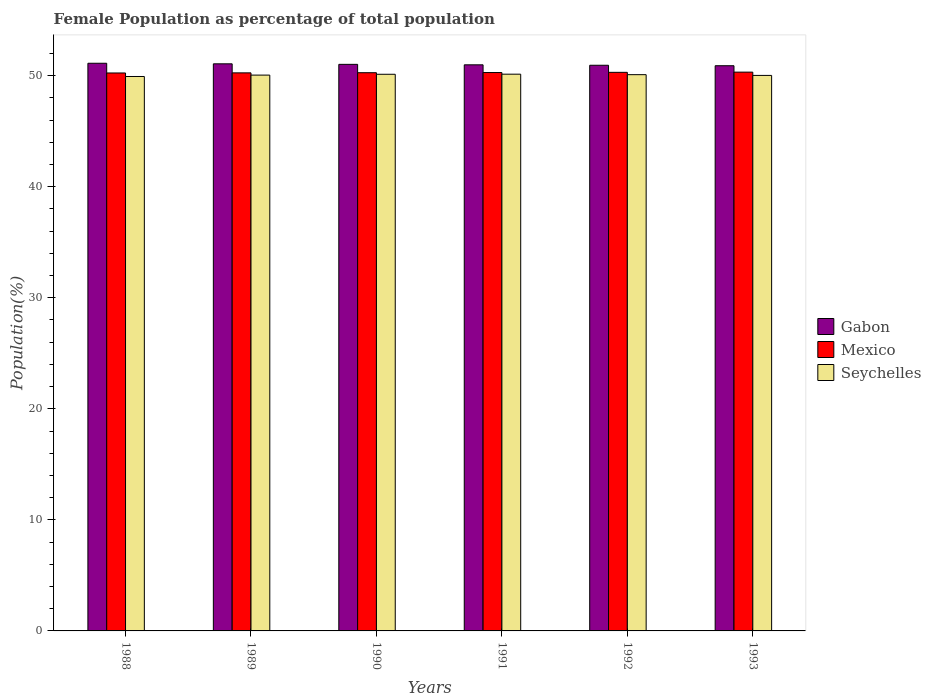Are the number of bars on each tick of the X-axis equal?
Ensure brevity in your answer.  Yes. In how many cases, is the number of bars for a given year not equal to the number of legend labels?
Your response must be concise. 0. What is the female population in in Gabon in 1991?
Offer a very short reply. 50.98. Across all years, what is the maximum female population in in Seychelles?
Ensure brevity in your answer.  50.13. Across all years, what is the minimum female population in in Seychelles?
Provide a short and direct response. 49.93. In which year was the female population in in Seychelles maximum?
Your answer should be compact. 1991. What is the total female population in in Seychelles in the graph?
Provide a succinct answer. 300.35. What is the difference between the female population in in Gabon in 1990 and that in 1992?
Offer a terse response. 0.08. What is the difference between the female population in in Seychelles in 1988 and the female population in in Mexico in 1990?
Your answer should be very brief. -0.34. What is the average female population in in Mexico per year?
Keep it short and to the point. 50.28. In the year 1990, what is the difference between the female population in in Seychelles and female population in in Mexico?
Give a very brief answer. -0.14. What is the ratio of the female population in in Seychelles in 1990 to that in 1992?
Keep it short and to the point. 1. Is the difference between the female population in in Seychelles in 1990 and 1992 greater than the difference between the female population in in Mexico in 1990 and 1992?
Your response must be concise. Yes. What is the difference between the highest and the second highest female population in in Mexico?
Offer a terse response. 0.02. What is the difference between the highest and the lowest female population in in Mexico?
Give a very brief answer. 0.08. In how many years, is the female population in in Seychelles greater than the average female population in in Seychelles taken over all years?
Give a very brief answer. 3. Is the sum of the female population in in Gabon in 1990 and 1991 greater than the maximum female population in in Seychelles across all years?
Your answer should be compact. Yes. What does the 3rd bar from the left in 1993 represents?
Make the answer very short. Seychelles. What does the 3rd bar from the right in 1989 represents?
Keep it short and to the point. Gabon. Are all the bars in the graph horizontal?
Your response must be concise. No. How many years are there in the graph?
Keep it short and to the point. 6. What is the difference between two consecutive major ticks on the Y-axis?
Give a very brief answer. 10. Are the values on the major ticks of Y-axis written in scientific E-notation?
Your response must be concise. No. Does the graph contain grids?
Ensure brevity in your answer.  No. Where does the legend appear in the graph?
Your answer should be compact. Center right. What is the title of the graph?
Keep it short and to the point. Female Population as percentage of total population. Does "Tonga" appear as one of the legend labels in the graph?
Keep it short and to the point. No. What is the label or title of the X-axis?
Your answer should be compact. Years. What is the label or title of the Y-axis?
Your answer should be very brief. Population(%). What is the Population(%) of Gabon in 1988?
Provide a succinct answer. 51.12. What is the Population(%) in Mexico in 1988?
Your answer should be very brief. 50.24. What is the Population(%) in Seychelles in 1988?
Provide a succinct answer. 49.93. What is the Population(%) in Gabon in 1989?
Make the answer very short. 51.07. What is the Population(%) of Mexico in 1989?
Your answer should be compact. 50.25. What is the Population(%) in Seychelles in 1989?
Offer a very short reply. 50.05. What is the Population(%) of Gabon in 1990?
Your answer should be very brief. 51.02. What is the Population(%) in Mexico in 1990?
Make the answer very short. 50.27. What is the Population(%) of Seychelles in 1990?
Your answer should be very brief. 50.13. What is the Population(%) in Gabon in 1991?
Your answer should be compact. 50.98. What is the Population(%) in Mexico in 1991?
Your answer should be compact. 50.28. What is the Population(%) of Seychelles in 1991?
Ensure brevity in your answer.  50.13. What is the Population(%) of Gabon in 1992?
Make the answer very short. 50.94. What is the Population(%) of Mexico in 1992?
Keep it short and to the point. 50.3. What is the Population(%) of Seychelles in 1992?
Ensure brevity in your answer.  50.09. What is the Population(%) of Gabon in 1993?
Your answer should be very brief. 50.89. What is the Population(%) of Mexico in 1993?
Provide a short and direct response. 50.32. What is the Population(%) of Seychelles in 1993?
Provide a succinct answer. 50.02. Across all years, what is the maximum Population(%) of Gabon?
Provide a succinct answer. 51.12. Across all years, what is the maximum Population(%) of Mexico?
Ensure brevity in your answer.  50.32. Across all years, what is the maximum Population(%) in Seychelles?
Provide a succinct answer. 50.13. Across all years, what is the minimum Population(%) of Gabon?
Offer a very short reply. 50.89. Across all years, what is the minimum Population(%) in Mexico?
Offer a terse response. 50.24. Across all years, what is the minimum Population(%) of Seychelles?
Keep it short and to the point. 49.93. What is the total Population(%) in Gabon in the graph?
Offer a terse response. 306.01. What is the total Population(%) of Mexico in the graph?
Make the answer very short. 301.66. What is the total Population(%) of Seychelles in the graph?
Your answer should be compact. 300.35. What is the difference between the Population(%) of Gabon in 1988 and that in 1989?
Give a very brief answer. 0.05. What is the difference between the Population(%) in Mexico in 1988 and that in 1989?
Make the answer very short. -0.01. What is the difference between the Population(%) of Seychelles in 1988 and that in 1989?
Offer a terse response. -0.13. What is the difference between the Population(%) of Gabon in 1988 and that in 1990?
Ensure brevity in your answer.  0.1. What is the difference between the Population(%) of Mexico in 1988 and that in 1990?
Ensure brevity in your answer.  -0.02. What is the difference between the Population(%) of Seychelles in 1988 and that in 1990?
Provide a short and direct response. -0.2. What is the difference between the Population(%) of Gabon in 1988 and that in 1991?
Your answer should be compact. 0.14. What is the difference between the Population(%) in Mexico in 1988 and that in 1991?
Provide a succinct answer. -0.04. What is the difference between the Population(%) in Seychelles in 1988 and that in 1991?
Offer a terse response. -0.21. What is the difference between the Population(%) in Gabon in 1988 and that in 1992?
Your answer should be very brief. 0.18. What is the difference between the Population(%) in Mexico in 1988 and that in 1992?
Provide a succinct answer. -0.06. What is the difference between the Population(%) of Seychelles in 1988 and that in 1992?
Provide a short and direct response. -0.17. What is the difference between the Population(%) in Gabon in 1988 and that in 1993?
Keep it short and to the point. 0.22. What is the difference between the Population(%) of Mexico in 1988 and that in 1993?
Ensure brevity in your answer.  -0.08. What is the difference between the Population(%) of Seychelles in 1988 and that in 1993?
Keep it short and to the point. -0.1. What is the difference between the Population(%) in Gabon in 1989 and that in 1990?
Give a very brief answer. 0.05. What is the difference between the Population(%) in Mexico in 1989 and that in 1990?
Offer a very short reply. -0.01. What is the difference between the Population(%) of Seychelles in 1989 and that in 1990?
Ensure brevity in your answer.  -0.07. What is the difference between the Population(%) in Gabon in 1989 and that in 1991?
Offer a very short reply. 0.09. What is the difference between the Population(%) in Mexico in 1989 and that in 1991?
Provide a succinct answer. -0.03. What is the difference between the Population(%) in Seychelles in 1989 and that in 1991?
Your answer should be very brief. -0.08. What is the difference between the Population(%) of Gabon in 1989 and that in 1992?
Provide a succinct answer. 0.13. What is the difference between the Population(%) of Mexico in 1989 and that in 1992?
Ensure brevity in your answer.  -0.05. What is the difference between the Population(%) of Seychelles in 1989 and that in 1992?
Provide a short and direct response. -0.04. What is the difference between the Population(%) of Gabon in 1989 and that in 1993?
Ensure brevity in your answer.  0.17. What is the difference between the Population(%) in Mexico in 1989 and that in 1993?
Keep it short and to the point. -0.07. What is the difference between the Population(%) in Seychelles in 1989 and that in 1993?
Your answer should be compact. 0.03. What is the difference between the Population(%) in Gabon in 1990 and that in 1991?
Your answer should be compact. 0.04. What is the difference between the Population(%) in Mexico in 1990 and that in 1991?
Offer a terse response. -0.02. What is the difference between the Population(%) in Seychelles in 1990 and that in 1991?
Offer a terse response. -0.01. What is the difference between the Population(%) in Gabon in 1990 and that in 1992?
Keep it short and to the point. 0.08. What is the difference between the Population(%) in Mexico in 1990 and that in 1992?
Offer a terse response. -0.03. What is the difference between the Population(%) in Seychelles in 1990 and that in 1992?
Offer a very short reply. 0.03. What is the difference between the Population(%) in Gabon in 1990 and that in 1993?
Offer a terse response. 0.12. What is the difference between the Population(%) in Mexico in 1990 and that in 1993?
Provide a succinct answer. -0.05. What is the difference between the Population(%) of Seychelles in 1990 and that in 1993?
Offer a very short reply. 0.1. What is the difference between the Population(%) in Gabon in 1991 and that in 1992?
Ensure brevity in your answer.  0.04. What is the difference between the Population(%) of Mexico in 1991 and that in 1992?
Give a very brief answer. -0.02. What is the difference between the Population(%) of Seychelles in 1991 and that in 1992?
Your answer should be very brief. 0.04. What is the difference between the Population(%) of Gabon in 1991 and that in 1993?
Give a very brief answer. 0.08. What is the difference between the Population(%) in Mexico in 1991 and that in 1993?
Ensure brevity in your answer.  -0.04. What is the difference between the Population(%) of Seychelles in 1991 and that in 1993?
Make the answer very short. 0.11. What is the difference between the Population(%) in Gabon in 1992 and that in 1993?
Your answer should be compact. 0.04. What is the difference between the Population(%) in Mexico in 1992 and that in 1993?
Your answer should be compact. -0.02. What is the difference between the Population(%) in Seychelles in 1992 and that in 1993?
Ensure brevity in your answer.  0.07. What is the difference between the Population(%) in Gabon in 1988 and the Population(%) in Mexico in 1989?
Keep it short and to the point. 0.86. What is the difference between the Population(%) of Gabon in 1988 and the Population(%) of Seychelles in 1989?
Your answer should be compact. 1.07. What is the difference between the Population(%) in Mexico in 1988 and the Population(%) in Seychelles in 1989?
Give a very brief answer. 0.19. What is the difference between the Population(%) of Gabon in 1988 and the Population(%) of Mexico in 1990?
Keep it short and to the point. 0.85. What is the difference between the Population(%) in Mexico in 1988 and the Population(%) in Seychelles in 1990?
Make the answer very short. 0.12. What is the difference between the Population(%) of Gabon in 1988 and the Population(%) of Mexico in 1991?
Give a very brief answer. 0.84. What is the difference between the Population(%) in Gabon in 1988 and the Population(%) in Seychelles in 1991?
Your response must be concise. 0.98. What is the difference between the Population(%) of Mexico in 1988 and the Population(%) of Seychelles in 1991?
Ensure brevity in your answer.  0.11. What is the difference between the Population(%) in Gabon in 1988 and the Population(%) in Mexico in 1992?
Offer a terse response. 0.82. What is the difference between the Population(%) in Gabon in 1988 and the Population(%) in Seychelles in 1992?
Provide a succinct answer. 1.03. What is the difference between the Population(%) of Mexico in 1988 and the Population(%) of Seychelles in 1992?
Ensure brevity in your answer.  0.15. What is the difference between the Population(%) of Gabon in 1988 and the Population(%) of Mexico in 1993?
Ensure brevity in your answer.  0.8. What is the difference between the Population(%) of Gabon in 1988 and the Population(%) of Seychelles in 1993?
Keep it short and to the point. 1.09. What is the difference between the Population(%) of Mexico in 1988 and the Population(%) of Seychelles in 1993?
Provide a succinct answer. 0.22. What is the difference between the Population(%) of Gabon in 1989 and the Population(%) of Mexico in 1990?
Give a very brief answer. 0.8. What is the difference between the Population(%) in Gabon in 1989 and the Population(%) in Seychelles in 1990?
Provide a short and direct response. 0.94. What is the difference between the Population(%) in Mexico in 1989 and the Population(%) in Seychelles in 1990?
Provide a succinct answer. 0.13. What is the difference between the Population(%) in Gabon in 1989 and the Population(%) in Mexico in 1991?
Provide a short and direct response. 0.78. What is the difference between the Population(%) of Gabon in 1989 and the Population(%) of Seychelles in 1991?
Provide a short and direct response. 0.93. What is the difference between the Population(%) in Mexico in 1989 and the Population(%) in Seychelles in 1991?
Your response must be concise. 0.12. What is the difference between the Population(%) of Gabon in 1989 and the Population(%) of Mexico in 1992?
Your response must be concise. 0.77. What is the difference between the Population(%) of Gabon in 1989 and the Population(%) of Seychelles in 1992?
Ensure brevity in your answer.  0.98. What is the difference between the Population(%) in Mexico in 1989 and the Population(%) in Seychelles in 1992?
Your answer should be very brief. 0.16. What is the difference between the Population(%) in Gabon in 1989 and the Population(%) in Mexico in 1993?
Provide a short and direct response. 0.75. What is the difference between the Population(%) in Gabon in 1989 and the Population(%) in Seychelles in 1993?
Give a very brief answer. 1.04. What is the difference between the Population(%) in Mexico in 1989 and the Population(%) in Seychelles in 1993?
Offer a terse response. 0.23. What is the difference between the Population(%) of Gabon in 1990 and the Population(%) of Mexico in 1991?
Provide a succinct answer. 0.74. What is the difference between the Population(%) of Gabon in 1990 and the Population(%) of Seychelles in 1991?
Ensure brevity in your answer.  0.89. What is the difference between the Population(%) of Mexico in 1990 and the Population(%) of Seychelles in 1991?
Give a very brief answer. 0.13. What is the difference between the Population(%) in Gabon in 1990 and the Population(%) in Mexico in 1992?
Give a very brief answer. 0.72. What is the difference between the Population(%) of Gabon in 1990 and the Population(%) of Seychelles in 1992?
Offer a terse response. 0.93. What is the difference between the Population(%) in Mexico in 1990 and the Population(%) in Seychelles in 1992?
Your answer should be very brief. 0.18. What is the difference between the Population(%) of Gabon in 1990 and the Population(%) of Mexico in 1993?
Your response must be concise. 0.7. What is the difference between the Population(%) in Gabon in 1990 and the Population(%) in Seychelles in 1993?
Your answer should be compact. 1. What is the difference between the Population(%) of Mexico in 1990 and the Population(%) of Seychelles in 1993?
Provide a short and direct response. 0.24. What is the difference between the Population(%) in Gabon in 1991 and the Population(%) in Mexico in 1992?
Keep it short and to the point. 0.68. What is the difference between the Population(%) in Gabon in 1991 and the Population(%) in Seychelles in 1992?
Your response must be concise. 0.89. What is the difference between the Population(%) of Mexico in 1991 and the Population(%) of Seychelles in 1992?
Offer a very short reply. 0.19. What is the difference between the Population(%) in Gabon in 1991 and the Population(%) in Mexico in 1993?
Provide a succinct answer. 0.66. What is the difference between the Population(%) of Gabon in 1991 and the Population(%) of Seychelles in 1993?
Your response must be concise. 0.95. What is the difference between the Population(%) of Mexico in 1991 and the Population(%) of Seychelles in 1993?
Give a very brief answer. 0.26. What is the difference between the Population(%) in Gabon in 1992 and the Population(%) in Mexico in 1993?
Give a very brief answer. 0.62. What is the difference between the Population(%) in Gabon in 1992 and the Population(%) in Seychelles in 1993?
Give a very brief answer. 0.91. What is the difference between the Population(%) of Mexico in 1992 and the Population(%) of Seychelles in 1993?
Your response must be concise. 0.28. What is the average Population(%) in Gabon per year?
Give a very brief answer. 51. What is the average Population(%) in Mexico per year?
Ensure brevity in your answer.  50.28. What is the average Population(%) of Seychelles per year?
Provide a succinct answer. 50.06. In the year 1988, what is the difference between the Population(%) in Gabon and Population(%) in Mexico?
Provide a succinct answer. 0.88. In the year 1988, what is the difference between the Population(%) of Gabon and Population(%) of Seychelles?
Give a very brief answer. 1.19. In the year 1988, what is the difference between the Population(%) in Mexico and Population(%) in Seychelles?
Offer a terse response. 0.32. In the year 1989, what is the difference between the Population(%) of Gabon and Population(%) of Mexico?
Make the answer very short. 0.81. In the year 1989, what is the difference between the Population(%) of Gabon and Population(%) of Seychelles?
Make the answer very short. 1.02. In the year 1989, what is the difference between the Population(%) of Mexico and Population(%) of Seychelles?
Your response must be concise. 0.2. In the year 1990, what is the difference between the Population(%) of Gabon and Population(%) of Mexico?
Offer a very short reply. 0.75. In the year 1990, what is the difference between the Population(%) of Gabon and Population(%) of Seychelles?
Provide a short and direct response. 0.89. In the year 1990, what is the difference between the Population(%) in Mexico and Population(%) in Seychelles?
Offer a very short reply. 0.14. In the year 1991, what is the difference between the Population(%) in Gabon and Population(%) in Mexico?
Your response must be concise. 0.69. In the year 1991, what is the difference between the Population(%) of Gabon and Population(%) of Seychelles?
Offer a very short reply. 0.84. In the year 1991, what is the difference between the Population(%) of Mexico and Population(%) of Seychelles?
Provide a succinct answer. 0.15. In the year 1992, what is the difference between the Population(%) of Gabon and Population(%) of Mexico?
Ensure brevity in your answer.  0.64. In the year 1992, what is the difference between the Population(%) of Gabon and Population(%) of Seychelles?
Provide a short and direct response. 0.85. In the year 1992, what is the difference between the Population(%) of Mexico and Population(%) of Seychelles?
Your answer should be very brief. 0.21. In the year 1993, what is the difference between the Population(%) of Gabon and Population(%) of Mexico?
Your answer should be compact. 0.58. In the year 1993, what is the difference between the Population(%) of Gabon and Population(%) of Seychelles?
Your response must be concise. 0.87. In the year 1993, what is the difference between the Population(%) of Mexico and Population(%) of Seychelles?
Offer a terse response. 0.3. What is the ratio of the Population(%) of Gabon in 1988 to that in 1989?
Keep it short and to the point. 1. What is the ratio of the Population(%) in Mexico in 1988 to that in 1989?
Provide a short and direct response. 1. What is the ratio of the Population(%) of Seychelles in 1988 to that in 1989?
Your response must be concise. 1. What is the ratio of the Population(%) of Mexico in 1988 to that in 1990?
Keep it short and to the point. 1. What is the ratio of the Population(%) in Seychelles in 1988 to that in 1990?
Provide a short and direct response. 1. What is the ratio of the Population(%) in Gabon in 1988 to that in 1991?
Provide a succinct answer. 1. What is the ratio of the Population(%) of Gabon in 1988 to that in 1992?
Give a very brief answer. 1. What is the ratio of the Population(%) in Mexico in 1988 to that in 1993?
Provide a succinct answer. 1. What is the ratio of the Population(%) of Seychelles in 1988 to that in 1993?
Make the answer very short. 1. What is the ratio of the Population(%) of Gabon in 1989 to that in 1990?
Offer a very short reply. 1. What is the ratio of the Population(%) of Mexico in 1989 to that in 1990?
Make the answer very short. 1. What is the ratio of the Population(%) of Mexico in 1989 to that in 1991?
Your answer should be very brief. 1. What is the ratio of the Population(%) in Gabon in 1989 to that in 1992?
Provide a succinct answer. 1. What is the ratio of the Population(%) of Mexico in 1989 to that in 1992?
Your response must be concise. 1. What is the ratio of the Population(%) in Seychelles in 1989 to that in 1992?
Provide a succinct answer. 1. What is the ratio of the Population(%) in Gabon in 1989 to that in 1993?
Provide a succinct answer. 1. What is the ratio of the Population(%) in Seychelles in 1989 to that in 1993?
Your answer should be very brief. 1. What is the ratio of the Population(%) in Mexico in 1990 to that in 1991?
Your response must be concise. 1. What is the ratio of the Population(%) in Seychelles in 1990 to that in 1993?
Keep it short and to the point. 1. What is the ratio of the Population(%) in Mexico in 1991 to that in 1992?
Your response must be concise. 1. What is the ratio of the Population(%) in Seychelles in 1992 to that in 1993?
Your response must be concise. 1. What is the difference between the highest and the second highest Population(%) of Gabon?
Give a very brief answer. 0.05. What is the difference between the highest and the second highest Population(%) in Mexico?
Your response must be concise. 0.02. What is the difference between the highest and the second highest Population(%) in Seychelles?
Your answer should be very brief. 0.01. What is the difference between the highest and the lowest Population(%) of Gabon?
Offer a terse response. 0.22. What is the difference between the highest and the lowest Population(%) in Mexico?
Give a very brief answer. 0.08. What is the difference between the highest and the lowest Population(%) in Seychelles?
Keep it short and to the point. 0.21. 